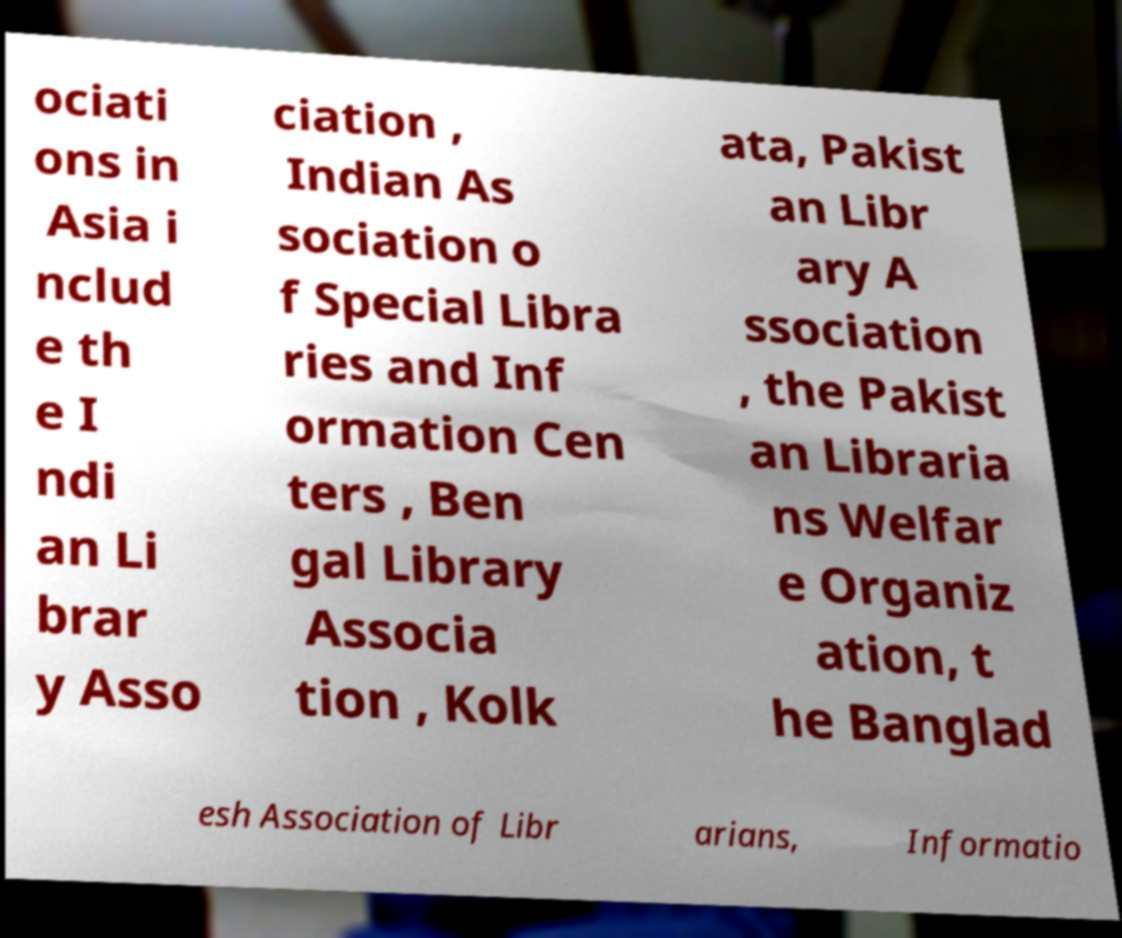Can you read and provide the text displayed in the image?This photo seems to have some interesting text. Can you extract and type it out for me? ociati ons in Asia i nclud e th e I ndi an Li brar y Asso ciation , Indian As sociation o f Special Libra ries and Inf ormation Cen ters , Ben gal Library Associa tion , Kolk ata, Pakist an Libr ary A ssociation , the Pakist an Libraria ns Welfar e Organiz ation, t he Banglad esh Association of Libr arians, Informatio 